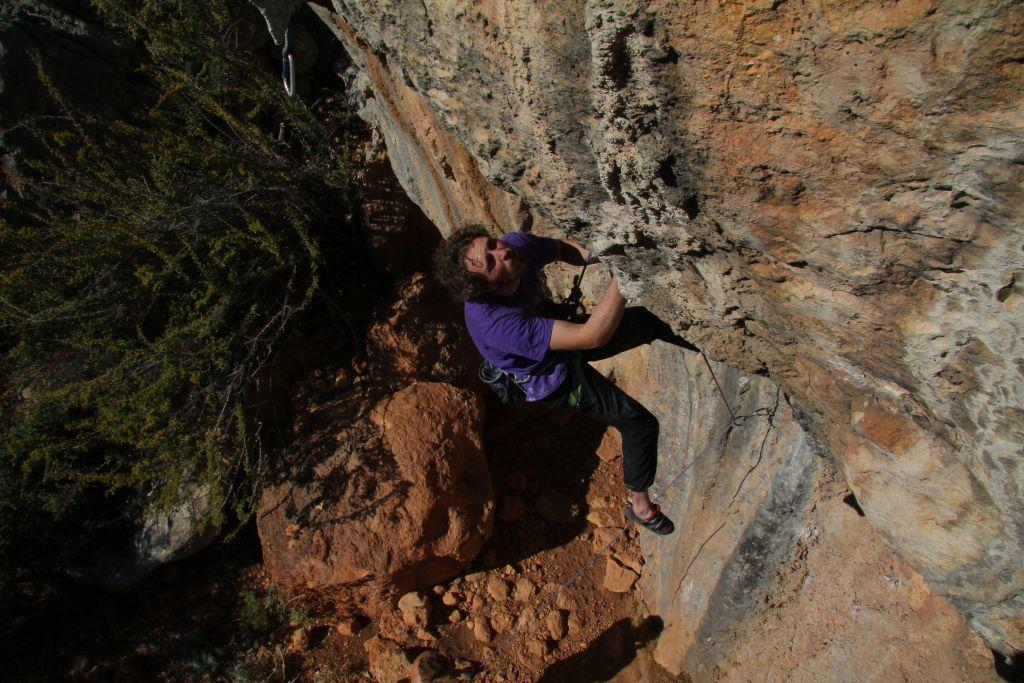Who is the person in the image? There is a man in the image. What is the man doing in the image? The man is climbing a rock. What tool is the man using to assist with his climb? The man is using a rope for climbing. What type of natural environment is visible in the image? There are trees visible in the image. What type of blade can be seen cutting through the trees in the image? There is no blade cutting through the trees in the image; the man is using a rope for climbing. 